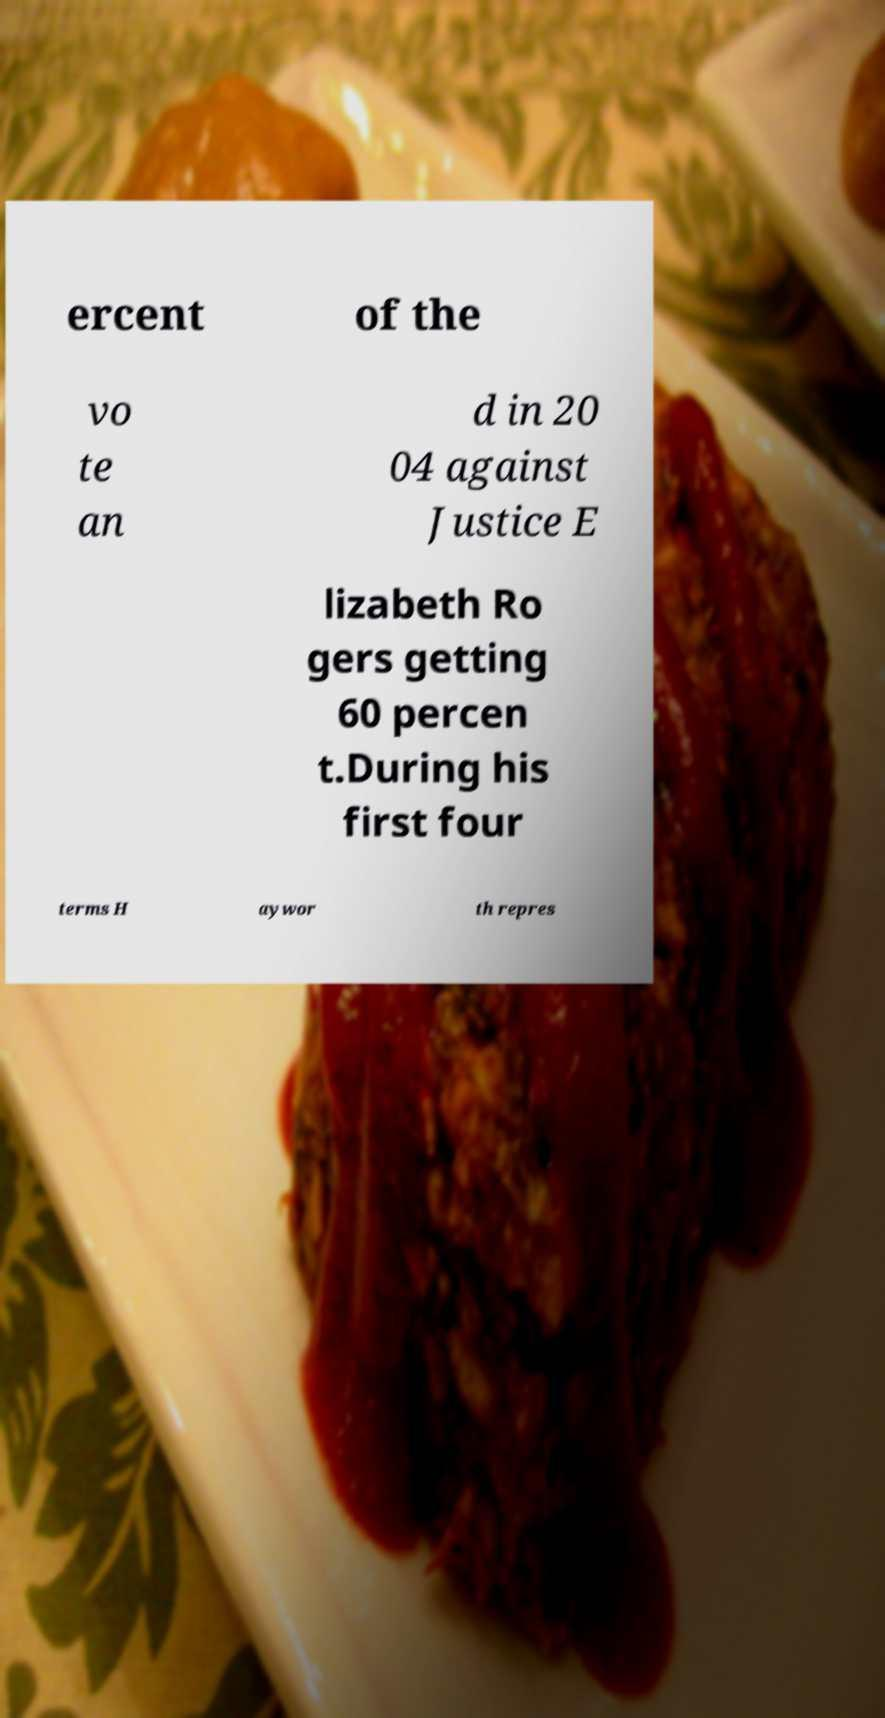Can you read and provide the text displayed in the image?This photo seems to have some interesting text. Can you extract and type it out for me? ercent of the vo te an d in 20 04 against Justice E lizabeth Ro gers getting 60 percen t.During his first four terms H aywor th repres 